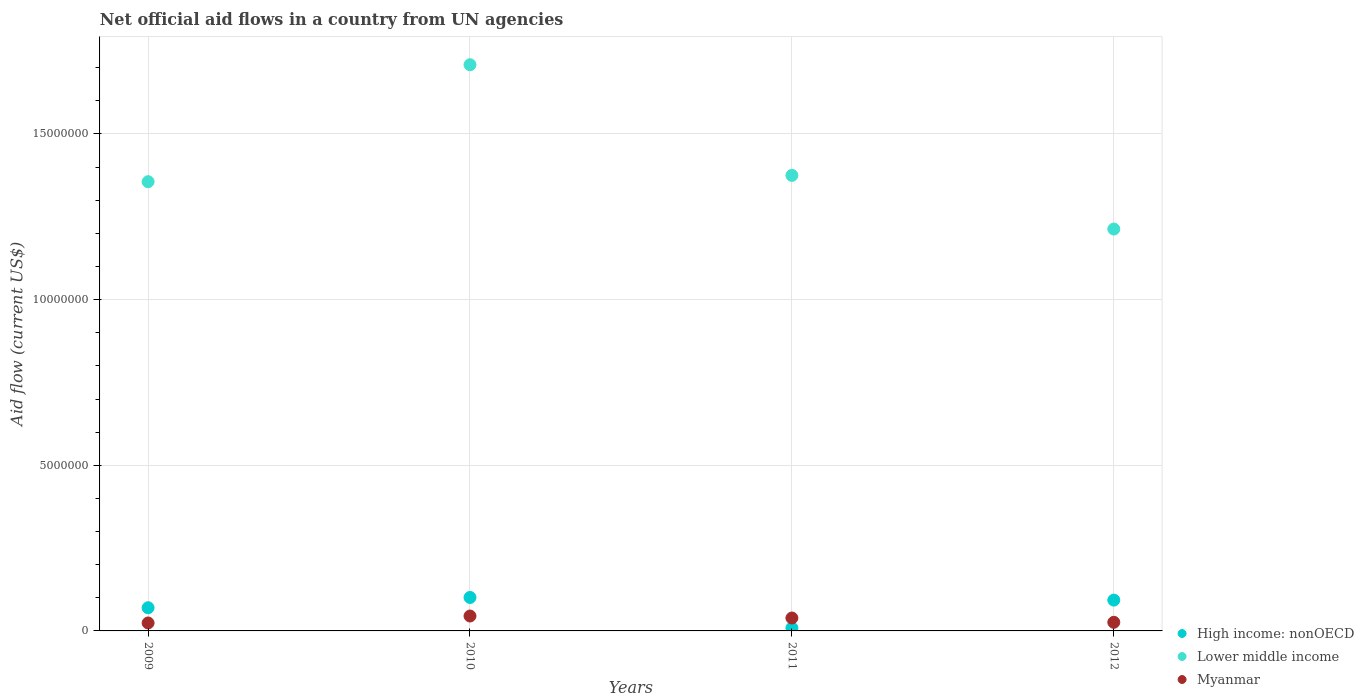Is the number of dotlines equal to the number of legend labels?
Keep it short and to the point. Yes. What is the net official aid flow in Lower middle income in 2010?
Give a very brief answer. 1.71e+07. Across all years, what is the maximum net official aid flow in Lower middle income?
Keep it short and to the point. 1.71e+07. Across all years, what is the minimum net official aid flow in High income: nonOECD?
Your answer should be very brief. 9.00e+04. What is the total net official aid flow in High income: nonOECD in the graph?
Keep it short and to the point. 2.73e+06. What is the difference between the net official aid flow in Lower middle income in 2009 and that in 2012?
Keep it short and to the point. 1.43e+06. What is the difference between the net official aid flow in Myanmar in 2011 and the net official aid flow in Lower middle income in 2009?
Ensure brevity in your answer.  -1.32e+07. What is the average net official aid flow in Lower middle income per year?
Your answer should be very brief. 1.41e+07. In the year 2012, what is the difference between the net official aid flow in Myanmar and net official aid flow in Lower middle income?
Ensure brevity in your answer.  -1.19e+07. What is the ratio of the net official aid flow in High income: nonOECD in 2009 to that in 2011?
Your answer should be very brief. 7.78. What is the difference between the highest and the second highest net official aid flow in High income: nonOECD?
Your response must be concise. 8.00e+04. What is the difference between the highest and the lowest net official aid flow in Myanmar?
Offer a terse response. 2.10e+05. In how many years, is the net official aid flow in High income: nonOECD greater than the average net official aid flow in High income: nonOECD taken over all years?
Offer a terse response. 3. Does the net official aid flow in High income: nonOECD monotonically increase over the years?
Provide a succinct answer. No. Is the net official aid flow in Myanmar strictly greater than the net official aid flow in High income: nonOECD over the years?
Provide a succinct answer. No. Is the net official aid flow in Myanmar strictly less than the net official aid flow in Lower middle income over the years?
Your answer should be compact. Yes. What is the title of the graph?
Provide a short and direct response. Net official aid flows in a country from UN agencies. Does "East Asia (developing only)" appear as one of the legend labels in the graph?
Ensure brevity in your answer.  No. What is the label or title of the X-axis?
Your answer should be compact. Years. What is the Aid flow (current US$) in High income: nonOECD in 2009?
Offer a terse response. 7.00e+05. What is the Aid flow (current US$) of Lower middle income in 2009?
Provide a short and direct response. 1.36e+07. What is the Aid flow (current US$) in Myanmar in 2009?
Provide a succinct answer. 2.40e+05. What is the Aid flow (current US$) in High income: nonOECD in 2010?
Keep it short and to the point. 1.01e+06. What is the Aid flow (current US$) in Lower middle income in 2010?
Keep it short and to the point. 1.71e+07. What is the Aid flow (current US$) of Myanmar in 2010?
Keep it short and to the point. 4.50e+05. What is the Aid flow (current US$) in High income: nonOECD in 2011?
Your answer should be very brief. 9.00e+04. What is the Aid flow (current US$) in Lower middle income in 2011?
Ensure brevity in your answer.  1.38e+07. What is the Aid flow (current US$) in Myanmar in 2011?
Offer a very short reply. 3.90e+05. What is the Aid flow (current US$) of High income: nonOECD in 2012?
Make the answer very short. 9.30e+05. What is the Aid flow (current US$) of Lower middle income in 2012?
Your response must be concise. 1.21e+07. Across all years, what is the maximum Aid flow (current US$) in High income: nonOECD?
Ensure brevity in your answer.  1.01e+06. Across all years, what is the maximum Aid flow (current US$) of Lower middle income?
Ensure brevity in your answer.  1.71e+07. Across all years, what is the maximum Aid flow (current US$) of Myanmar?
Make the answer very short. 4.50e+05. Across all years, what is the minimum Aid flow (current US$) of Lower middle income?
Your response must be concise. 1.21e+07. What is the total Aid flow (current US$) in High income: nonOECD in the graph?
Make the answer very short. 2.73e+06. What is the total Aid flow (current US$) in Lower middle income in the graph?
Provide a succinct answer. 5.65e+07. What is the total Aid flow (current US$) of Myanmar in the graph?
Your response must be concise. 1.34e+06. What is the difference between the Aid flow (current US$) in High income: nonOECD in 2009 and that in 2010?
Your response must be concise. -3.10e+05. What is the difference between the Aid flow (current US$) in Lower middle income in 2009 and that in 2010?
Give a very brief answer. -3.53e+06. What is the difference between the Aid flow (current US$) of Myanmar in 2009 and that in 2010?
Provide a short and direct response. -2.10e+05. What is the difference between the Aid flow (current US$) of Lower middle income in 2009 and that in 2012?
Give a very brief answer. 1.43e+06. What is the difference between the Aid flow (current US$) in Myanmar in 2009 and that in 2012?
Give a very brief answer. -2.00e+04. What is the difference between the Aid flow (current US$) of High income: nonOECD in 2010 and that in 2011?
Provide a succinct answer. 9.20e+05. What is the difference between the Aid flow (current US$) of Lower middle income in 2010 and that in 2011?
Make the answer very short. 3.34e+06. What is the difference between the Aid flow (current US$) of Lower middle income in 2010 and that in 2012?
Ensure brevity in your answer.  4.96e+06. What is the difference between the Aid flow (current US$) in Myanmar in 2010 and that in 2012?
Give a very brief answer. 1.90e+05. What is the difference between the Aid flow (current US$) of High income: nonOECD in 2011 and that in 2012?
Your answer should be compact. -8.40e+05. What is the difference between the Aid flow (current US$) of Lower middle income in 2011 and that in 2012?
Your answer should be compact. 1.62e+06. What is the difference between the Aid flow (current US$) of High income: nonOECD in 2009 and the Aid flow (current US$) of Lower middle income in 2010?
Your answer should be compact. -1.64e+07. What is the difference between the Aid flow (current US$) in High income: nonOECD in 2009 and the Aid flow (current US$) in Myanmar in 2010?
Offer a terse response. 2.50e+05. What is the difference between the Aid flow (current US$) of Lower middle income in 2009 and the Aid flow (current US$) of Myanmar in 2010?
Keep it short and to the point. 1.31e+07. What is the difference between the Aid flow (current US$) in High income: nonOECD in 2009 and the Aid flow (current US$) in Lower middle income in 2011?
Give a very brief answer. -1.30e+07. What is the difference between the Aid flow (current US$) in High income: nonOECD in 2009 and the Aid flow (current US$) in Myanmar in 2011?
Provide a short and direct response. 3.10e+05. What is the difference between the Aid flow (current US$) of Lower middle income in 2009 and the Aid flow (current US$) of Myanmar in 2011?
Give a very brief answer. 1.32e+07. What is the difference between the Aid flow (current US$) of High income: nonOECD in 2009 and the Aid flow (current US$) of Lower middle income in 2012?
Offer a terse response. -1.14e+07. What is the difference between the Aid flow (current US$) in High income: nonOECD in 2009 and the Aid flow (current US$) in Myanmar in 2012?
Offer a terse response. 4.40e+05. What is the difference between the Aid flow (current US$) in Lower middle income in 2009 and the Aid flow (current US$) in Myanmar in 2012?
Give a very brief answer. 1.33e+07. What is the difference between the Aid flow (current US$) of High income: nonOECD in 2010 and the Aid flow (current US$) of Lower middle income in 2011?
Provide a short and direct response. -1.27e+07. What is the difference between the Aid flow (current US$) in High income: nonOECD in 2010 and the Aid flow (current US$) in Myanmar in 2011?
Give a very brief answer. 6.20e+05. What is the difference between the Aid flow (current US$) of Lower middle income in 2010 and the Aid flow (current US$) of Myanmar in 2011?
Offer a terse response. 1.67e+07. What is the difference between the Aid flow (current US$) of High income: nonOECD in 2010 and the Aid flow (current US$) of Lower middle income in 2012?
Your response must be concise. -1.11e+07. What is the difference between the Aid flow (current US$) of High income: nonOECD in 2010 and the Aid flow (current US$) of Myanmar in 2012?
Give a very brief answer. 7.50e+05. What is the difference between the Aid flow (current US$) of Lower middle income in 2010 and the Aid flow (current US$) of Myanmar in 2012?
Keep it short and to the point. 1.68e+07. What is the difference between the Aid flow (current US$) of High income: nonOECD in 2011 and the Aid flow (current US$) of Lower middle income in 2012?
Your response must be concise. -1.20e+07. What is the difference between the Aid flow (current US$) of Lower middle income in 2011 and the Aid flow (current US$) of Myanmar in 2012?
Ensure brevity in your answer.  1.35e+07. What is the average Aid flow (current US$) of High income: nonOECD per year?
Provide a short and direct response. 6.82e+05. What is the average Aid flow (current US$) in Lower middle income per year?
Make the answer very short. 1.41e+07. What is the average Aid flow (current US$) in Myanmar per year?
Make the answer very short. 3.35e+05. In the year 2009, what is the difference between the Aid flow (current US$) in High income: nonOECD and Aid flow (current US$) in Lower middle income?
Offer a very short reply. -1.29e+07. In the year 2009, what is the difference between the Aid flow (current US$) in Lower middle income and Aid flow (current US$) in Myanmar?
Give a very brief answer. 1.33e+07. In the year 2010, what is the difference between the Aid flow (current US$) of High income: nonOECD and Aid flow (current US$) of Lower middle income?
Make the answer very short. -1.61e+07. In the year 2010, what is the difference between the Aid flow (current US$) of High income: nonOECD and Aid flow (current US$) of Myanmar?
Offer a terse response. 5.60e+05. In the year 2010, what is the difference between the Aid flow (current US$) of Lower middle income and Aid flow (current US$) of Myanmar?
Your answer should be compact. 1.66e+07. In the year 2011, what is the difference between the Aid flow (current US$) in High income: nonOECD and Aid flow (current US$) in Lower middle income?
Give a very brief answer. -1.37e+07. In the year 2011, what is the difference between the Aid flow (current US$) in High income: nonOECD and Aid flow (current US$) in Myanmar?
Provide a succinct answer. -3.00e+05. In the year 2011, what is the difference between the Aid flow (current US$) in Lower middle income and Aid flow (current US$) in Myanmar?
Provide a succinct answer. 1.34e+07. In the year 2012, what is the difference between the Aid flow (current US$) in High income: nonOECD and Aid flow (current US$) in Lower middle income?
Give a very brief answer. -1.12e+07. In the year 2012, what is the difference between the Aid flow (current US$) in High income: nonOECD and Aid flow (current US$) in Myanmar?
Offer a terse response. 6.70e+05. In the year 2012, what is the difference between the Aid flow (current US$) of Lower middle income and Aid flow (current US$) of Myanmar?
Offer a very short reply. 1.19e+07. What is the ratio of the Aid flow (current US$) of High income: nonOECD in 2009 to that in 2010?
Offer a terse response. 0.69. What is the ratio of the Aid flow (current US$) of Lower middle income in 2009 to that in 2010?
Your answer should be very brief. 0.79. What is the ratio of the Aid flow (current US$) of Myanmar in 2009 to that in 2010?
Your answer should be very brief. 0.53. What is the ratio of the Aid flow (current US$) of High income: nonOECD in 2009 to that in 2011?
Your response must be concise. 7.78. What is the ratio of the Aid flow (current US$) in Lower middle income in 2009 to that in 2011?
Ensure brevity in your answer.  0.99. What is the ratio of the Aid flow (current US$) in Myanmar in 2009 to that in 2011?
Offer a very short reply. 0.62. What is the ratio of the Aid flow (current US$) in High income: nonOECD in 2009 to that in 2012?
Your answer should be compact. 0.75. What is the ratio of the Aid flow (current US$) of Lower middle income in 2009 to that in 2012?
Ensure brevity in your answer.  1.12. What is the ratio of the Aid flow (current US$) of High income: nonOECD in 2010 to that in 2011?
Make the answer very short. 11.22. What is the ratio of the Aid flow (current US$) of Lower middle income in 2010 to that in 2011?
Make the answer very short. 1.24. What is the ratio of the Aid flow (current US$) in Myanmar in 2010 to that in 2011?
Your answer should be very brief. 1.15. What is the ratio of the Aid flow (current US$) of High income: nonOECD in 2010 to that in 2012?
Offer a terse response. 1.09. What is the ratio of the Aid flow (current US$) of Lower middle income in 2010 to that in 2012?
Make the answer very short. 1.41. What is the ratio of the Aid flow (current US$) of Myanmar in 2010 to that in 2012?
Provide a short and direct response. 1.73. What is the ratio of the Aid flow (current US$) of High income: nonOECD in 2011 to that in 2012?
Give a very brief answer. 0.1. What is the ratio of the Aid flow (current US$) in Lower middle income in 2011 to that in 2012?
Keep it short and to the point. 1.13. What is the ratio of the Aid flow (current US$) in Myanmar in 2011 to that in 2012?
Provide a succinct answer. 1.5. What is the difference between the highest and the second highest Aid flow (current US$) in High income: nonOECD?
Make the answer very short. 8.00e+04. What is the difference between the highest and the second highest Aid flow (current US$) of Lower middle income?
Your response must be concise. 3.34e+06. What is the difference between the highest and the lowest Aid flow (current US$) in High income: nonOECD?
Keep it short and to the point. 9.20e+05. What is the difference between the highest and the lowest Aid flow (current US$) of Lower middle income?
Provide a succinct answer. 4.96e+06. 